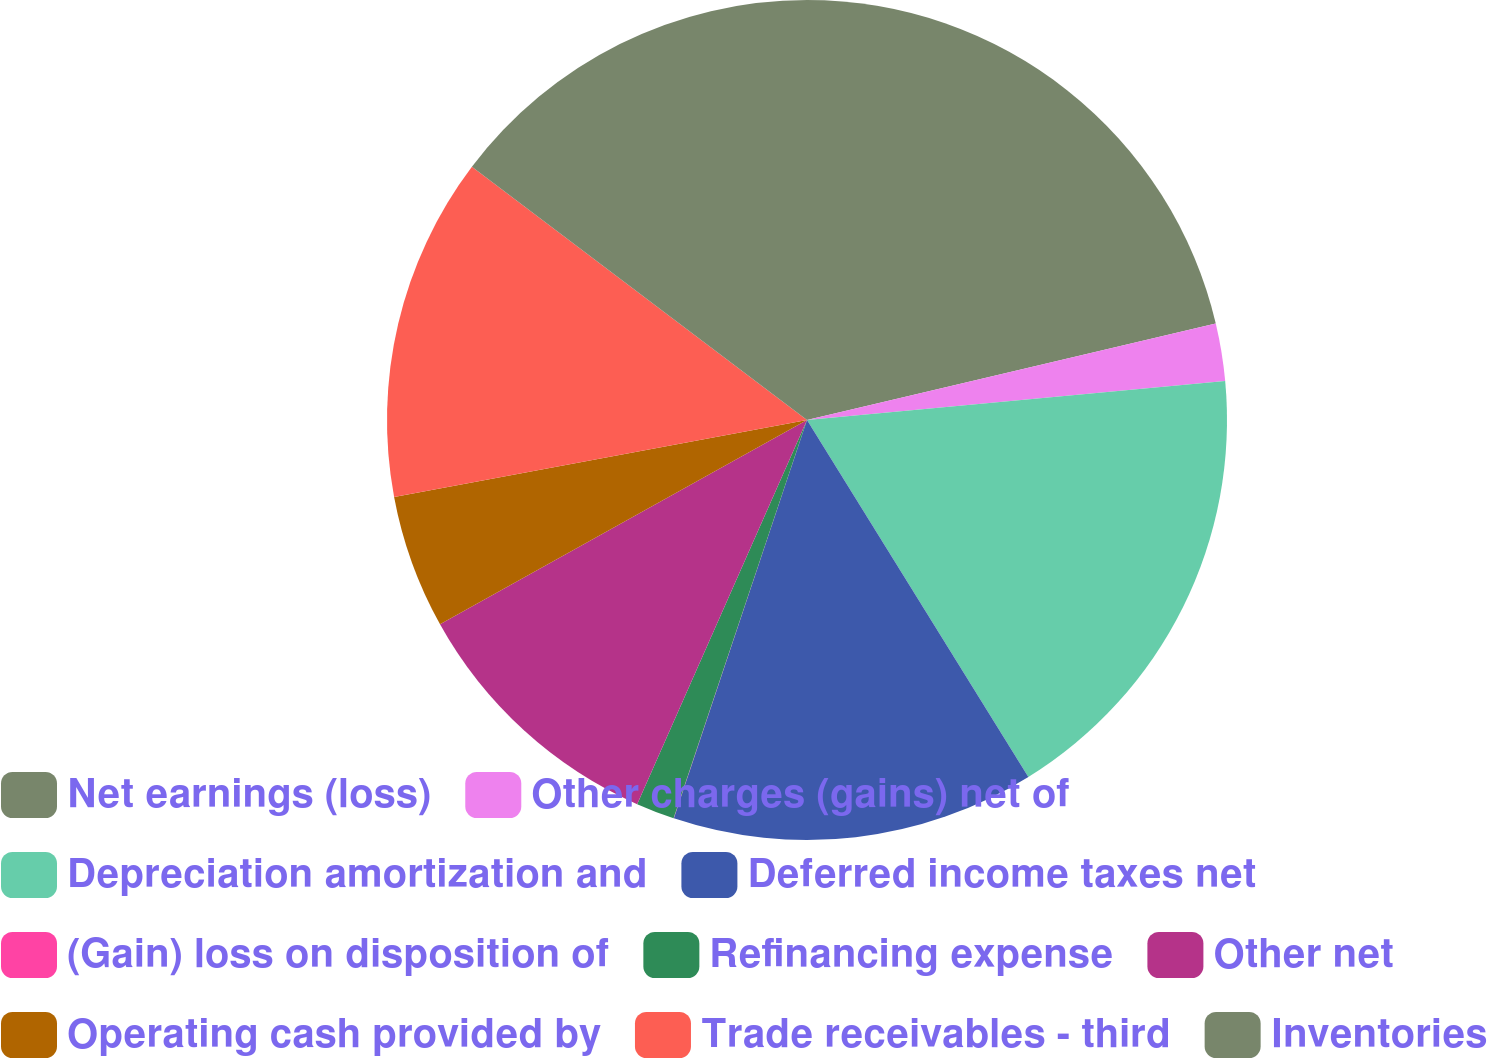Convert chart. <chart><loc_0><loc_0><loc_500><loc_500><pie_chart><fcel>Net earnings (loss)<fcel>Other charges (gains) net of<fcel>Depreciation amortization and<fcel>Deferred income taxes net<fcel>(Gain) loss on disposition of<fcel>Refinancing expense<fcel>Other net<fcel>Operating cash provided by<fcel>Trade receivables - third<fcel>Inventories<nl><fcel>21.31%<fcel>2.21%<fcel>17.64%<fcel>13.97%<fcel>0.01%<fcel>1.48%<fcel>10.29%<fcel>5.15%<fcel>13.23%<fcel>14.7%<nl></chart> 